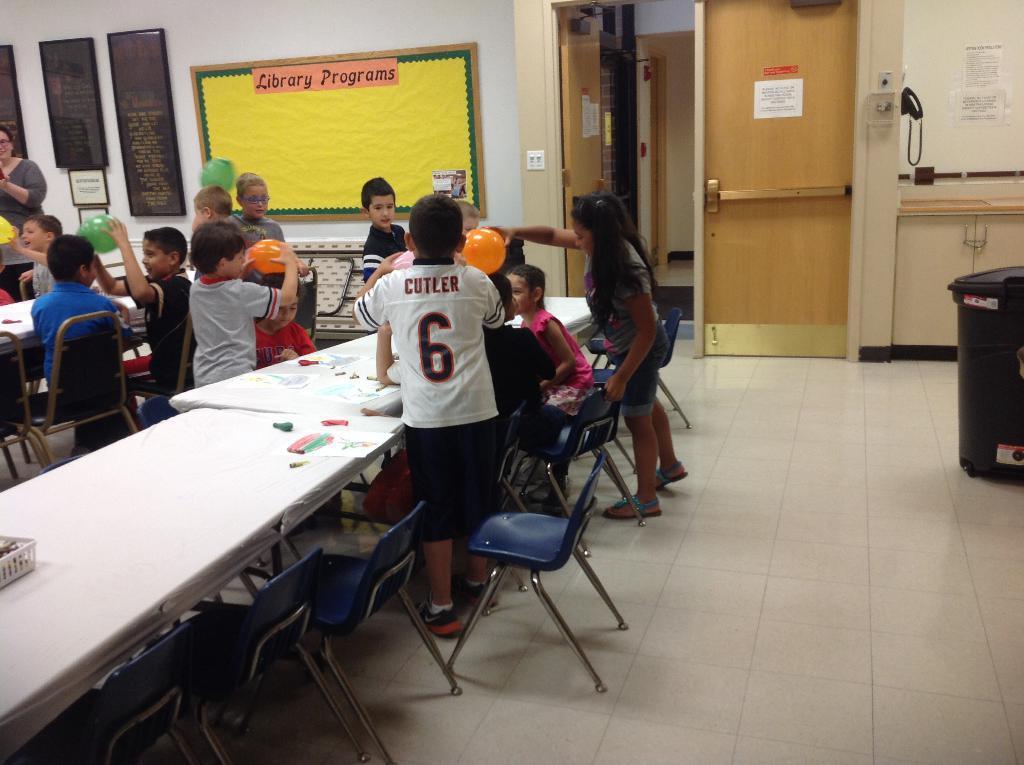Please provide a concise description of this image. In this picture There are few persons standing. These few persons sitting on the chair. there are tables. On this table we can see paper and things. We can see chairs. This is floor. In this background we can see wall, board,frame. This is door. 